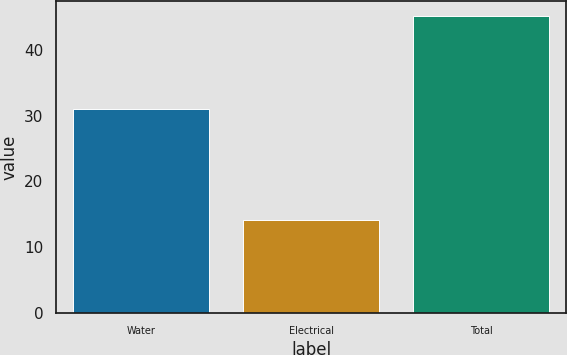Convert chart to OTSL. <chart><loc_0><loc_0><loc_500><loc_500><bar_chart><fcel>Water<fcel>Electrical<fcel>Total<nl><fcel>31.1<fcel>14.1<fcel>45.2<nl></chart> 